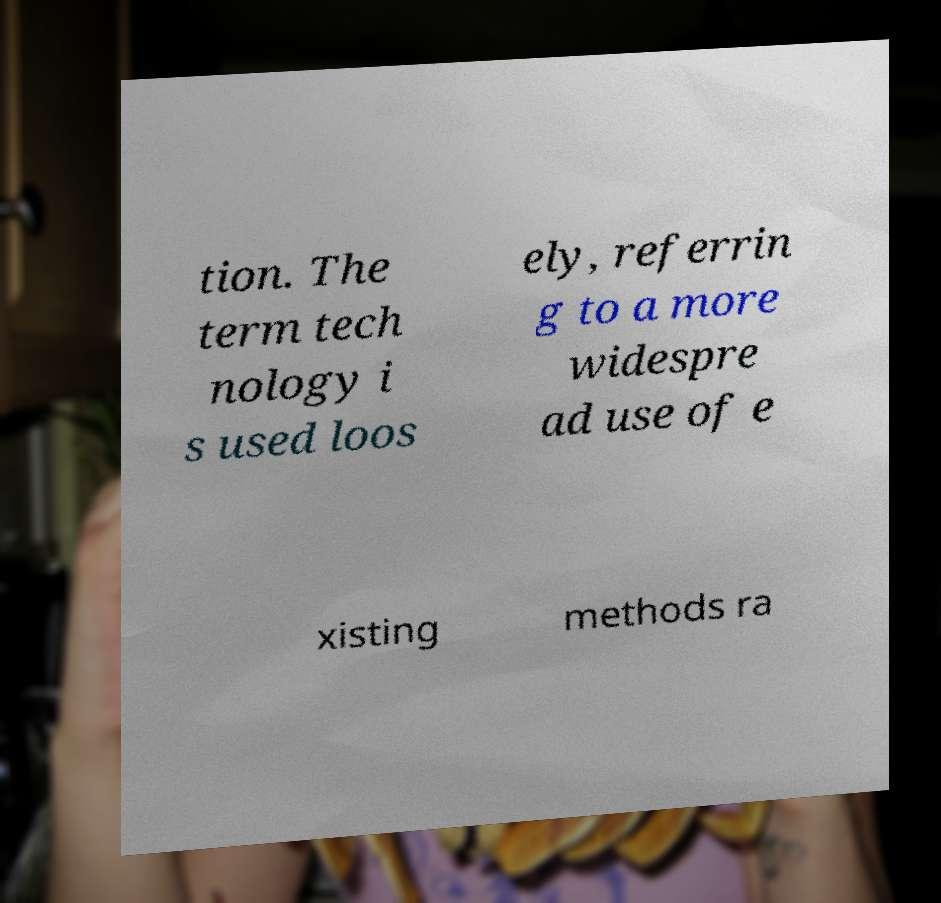Could you assist in decoding the text presented in this image and type it out clearly? tion. The term tech nology i s used loos ely, referrin g to a more widespre ad use of e xisting methods ra 